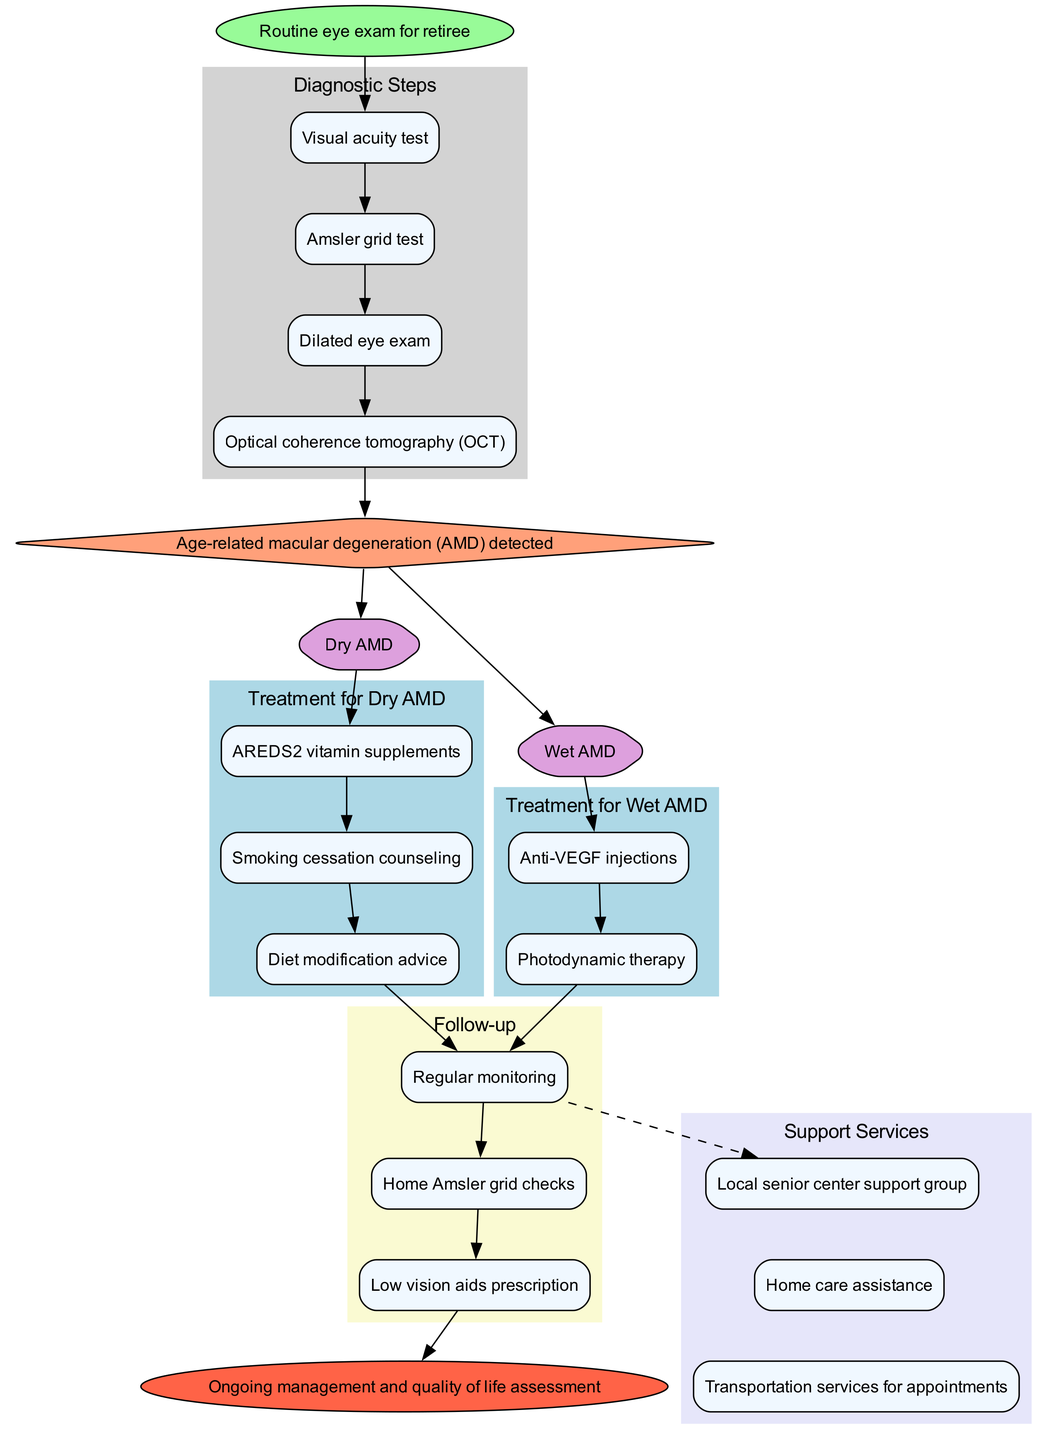What is the starting point of the clinical pathway? The starting point is indicated at the top of the diagram, labeled as "Routine eye exam for retiree." This node connects to the first diagnostic step.
Answer: Routine eye exam for retiree How many diagnostic steps are there in the pathway? The diagnostic steps are listed in a cluster within the diagram. There are a total of four steps: Visual acuity test, Amsler grid test, Dilated eye exam, and Optical coherence tomography (OCT). Thus, the number is counted to be four.
Answer: 4 What type of AMD is treated with anti-VEGF injections? The treatment options for AMD types are indicated and directly associated with the "Wet AMD" type. Since anti-VEGF injections are specifically listed under Wet AMD, it is evident that it is the treatment designated for this particular type.
Answer: Wet AMD What is one of the treatment options for Dry AMD? Under the Dry AMD treatment section, multiple options are provided; one of them is AREDS2 vitamin supplements. This is a direct answer taken from the treatment options in the diagram.
Answer: AREDS2 vitamin supplements What follows after the diagnosis of Age-related macular degeneration? After the diagnosis node, there are two branches representing the types of AMD (Dry AMD and Wet AMD). Following this branch, the flow leads into respective treatment options, making it clear that both branches lead to treatment options.
Answer: Treatment options What support service is available for retirees in the pathway? The support services are listed in a dedicated section near the end of the diagram. One example given is the "Local senior center support group," which is one of the services for ongoing support.
Answer: Local senior center support group How is the follow-up process structured in the pathway? The follow-up section contains three steps listed sequentially. They are regular monitoring, home Amsler grid checks, and low vision aids prescription. This structure indicates that they occur in the order listed.
Answer: Regular monitoring, home Amsler grid checks, low vision aids prescription What is the endpoint of the clinical pathway? The very last node in the diagram indicates the endpoint and is labeled "Ongoing management and quality of life assessment," which summarizes the goal of the clinical pathway for AMD management.
Answer: Ongoing management and quality of life assessment What color is used to represent the diagnosis node? The node labeled with the diagnosis of Age-related macular degeneration is distinctly colored in a light orange shade, which helps in visually categorizing it as a critical decision point in the pathway.
Answer: Light orange 